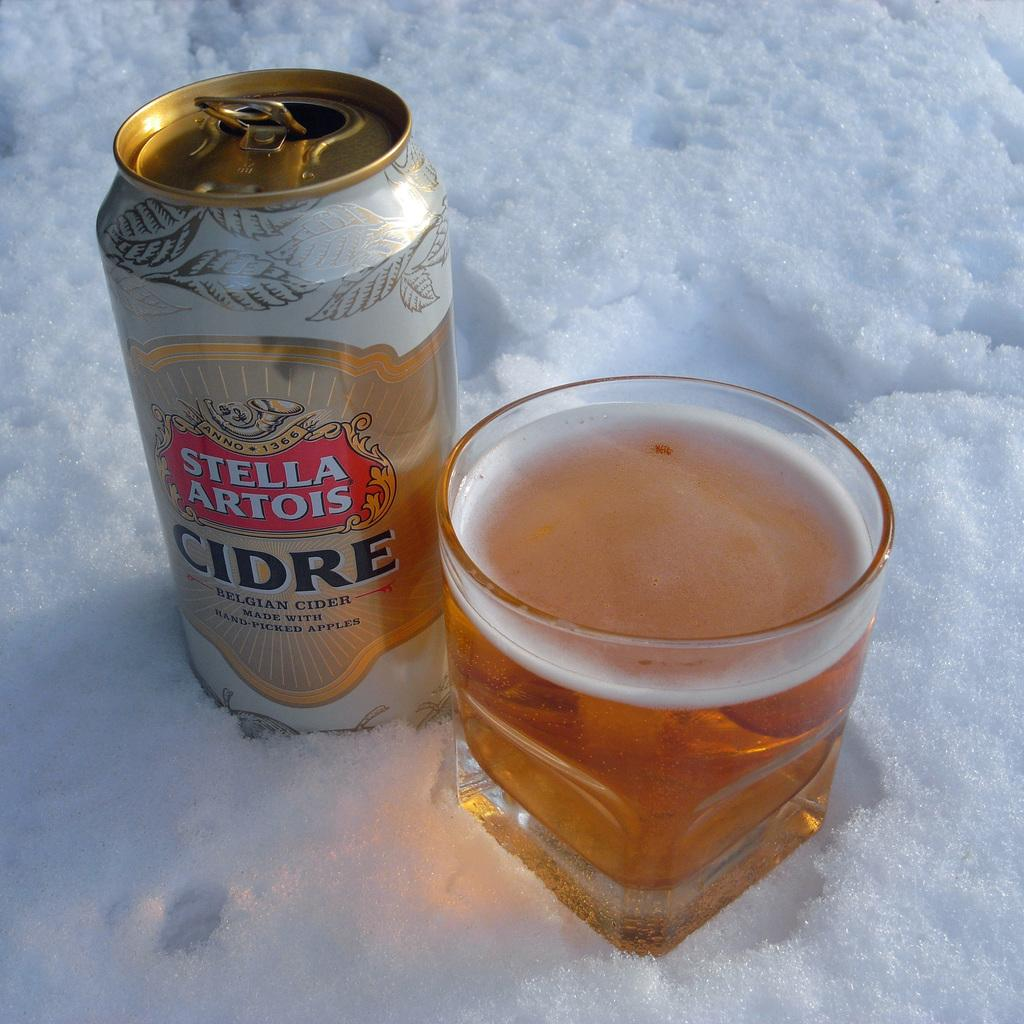What is the predominant weather condition in the image? There is snow in the image, indicating a cold and wintry setting. What objects can be seen in the image besides the snow? There is a can and a glass in the image. What is the glass holding? The glass contains liquid. Is there any text or information on the can? Yes, there is writing on the can. What time of day is depicted in the image? The time of day cannot be determined from the image, as there are no specific indicators of time. What type of friction is present between the snow and the objects in the image? The concept of friction is not applicable to the image, as it is a physical property that cannot be observed visually. 